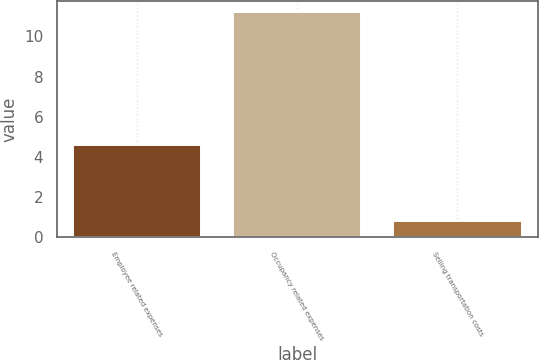<chart> <loc_0><loc_0><loc_500><loc_500><bar_chart><fcel>Employee related expenses<fcel>Occupancy related expenses<fcel>Selling transportation costs<nl><fcel>4.6<fcel>11.2<fcel>0.8<nl></chart> 